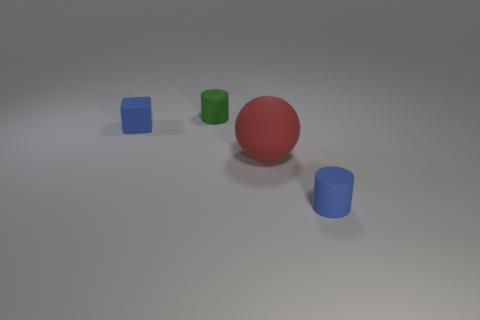Are there any other things that are made of the same material as the blue block?
Your answer should be compact. Yes. What is the material of the other small object that is the same shape as the green object?
Keep it short and to the point. Rubber. Do the big red ball and the blue cube have the same material?
Ensure brevity in your answer.  Yes. The matte thing that is behind the blue thing that is to the left of the tiny green rubber cylinder is what color?
Provide a succinct answer. Green. What is the size of the blue cylinder that is made of the same material as the red thing?
Keep it short and to the point. Small. What number of other rubber things are the same shape as the small green rubber thing?
Your answer should be very brief. 1. What number of objects are tiny rubber things in front of the green rubber cylinder or matte things on the left side of the blue cylinder?
Provide a short and direct response. 4. How many tiny matte things are on the left side of the tiny thing to the right of the large ball?
Keep it short and to the point. 2. Does the blue thing that is in front of the red matte thing have the same shape as the tiny rubber object to the left of the green matte cylinder?
Ensure brevity in your answer.  No. There is a tiny matte object that is the same color as the small block; what is its shape?
Your answer should be compact. Cylinder. 